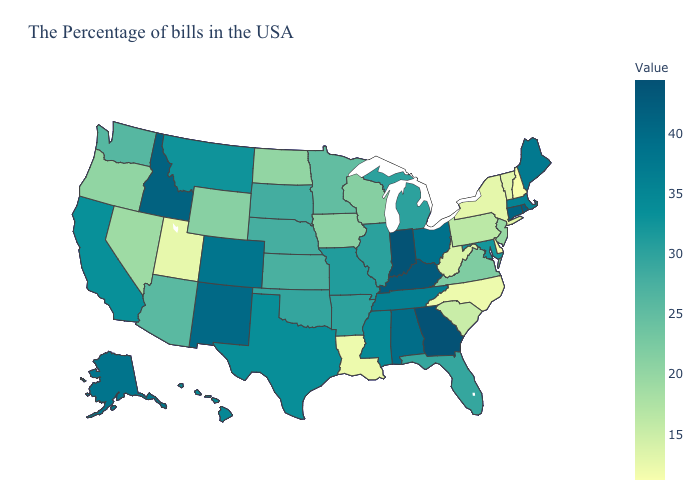Which states have the lowest value in the Northeast?
Concise answer only. New Hampshire. Does Virginia have a lower value than Montana?
Quick response, please. Yes. Is the legend a continuous bar?
Quick response, please. Yes. Among the states that border Connecticut , which have the lowest value?
Give a very brief answer. New York. Does Georgia have the highest value in the USA?
Give a very brief answer. Yes. Does Louisiana have the lowest value in the USA?
Write a very short answer. No. 